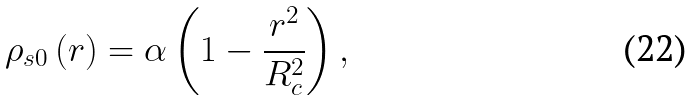<formula> <loc_0><loc_0><loc_500><loc_500>\rho _ { s 0 } \left ( r \right ) = \alpha \left ( 1 - \frac { r ^ { 2 } } { R _ { c } ^ { 2 } } \right ) ,</formula> 